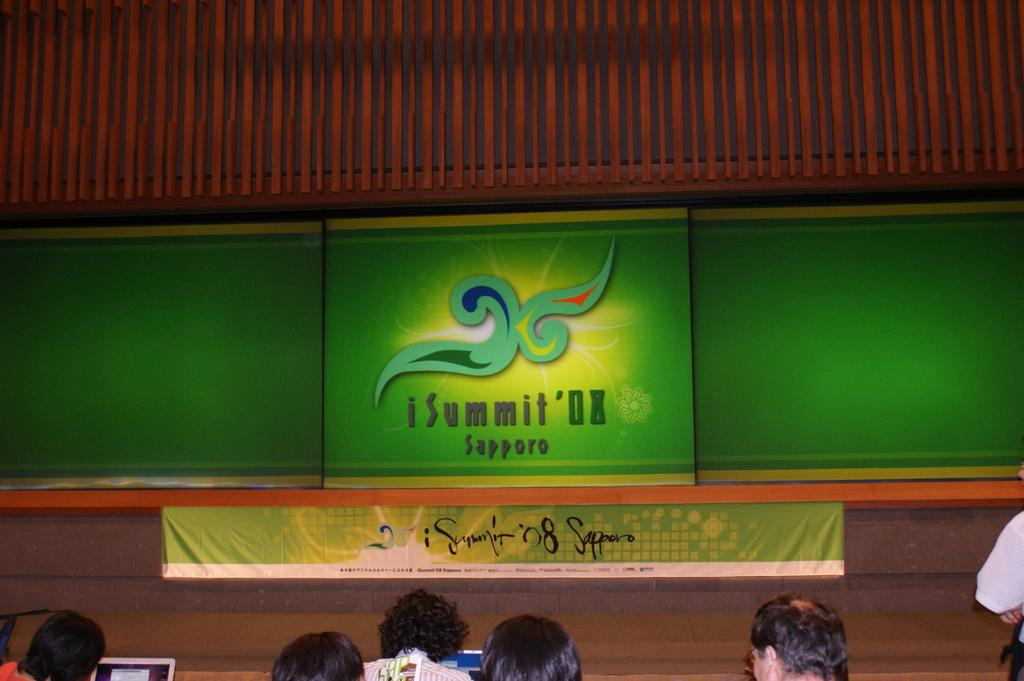What is located in the center of the image? There are screens in the center of the image. What else can be seen in the image besides the screens? There is a banner, people, laptops, and a roof visible in the image. Where are the people located in the image? The people are at the bottom of the image. What type of electronic devices are visible in the image? Laptops are visible in the image. What structure is present above the screens and people in the image? There is a roof in the image. Can you tell me how many matches are being played on the screens in the image? There is no information about matches being played on the screens in the image. What type of dog can be seen interacting with the people in the image? There is no dog present in the image; it features screens, a banner, people, laptops, and a roof. 